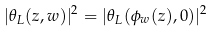<formula> <loc_0><loc_0><loc_500><loc_500>| \theta _ { L } ( z , w ) | ^ { 2 } = | \theta _ { L } ( \phi _ { w } ( z ) , 0 ) | ^ { 2 }</formula> 